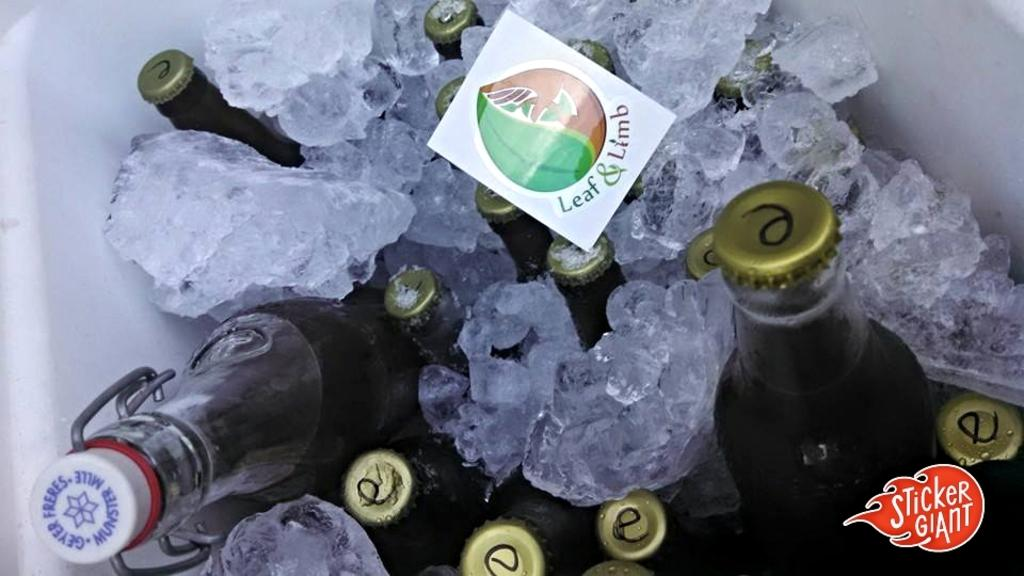<image>
Describe the image concisely. Bottles of beverages are nestled in ice with a Leaf & Limb sticker on top of one of the bottles. 